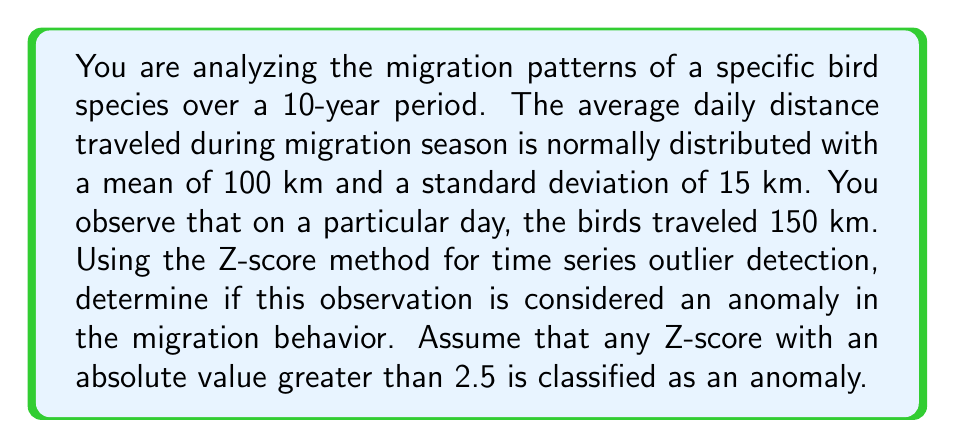Show me your answer to this math problem. To detect anomalies using the Z-score method in time series analysis, we follow these steps:

1. Calculate the Z-score for the observed value:
   The Z-score formula is:
   $$ Z = \frac{X - \mu}{\sigma} $$
   Where:
   $X$ is the observed value
   $\mu$ is the mean of the distribution
   $\sigma$ is the standard deviation of the distribution

2. In this case:
   $X = 150$ km (observed distance)
   $\mu = 100$ km (mean distance)
   $\sigma = 15$ km (standard deviation)

3. Plug these values into the Z-score formula:
   $$ Z = \frac{150 - 100}{15} = \frac{50}{15} = 3.33 $$

4. Interpret the result:
   The calculated Z-score is 3.33. Since we're using an absolute Z-score threshold of 2.5 to classify anomalies, we compare |3.33| to 2.5.

   |3.33| > 2.5

   Therefore, this observation is considered an anomaly in the migration behavior.

This method is particularly useful in your research on the genetic basis of migration, as it allows you to identify unusual migration behaviors that may be linked to genetic variations or environmental factors affecting the species.
Answer: Yes, the observation of 150 km traveled in one day is considered an anomaly in the migration behavior, with a Z-score of 3.33 which exceeds the threshold of 2.5. 